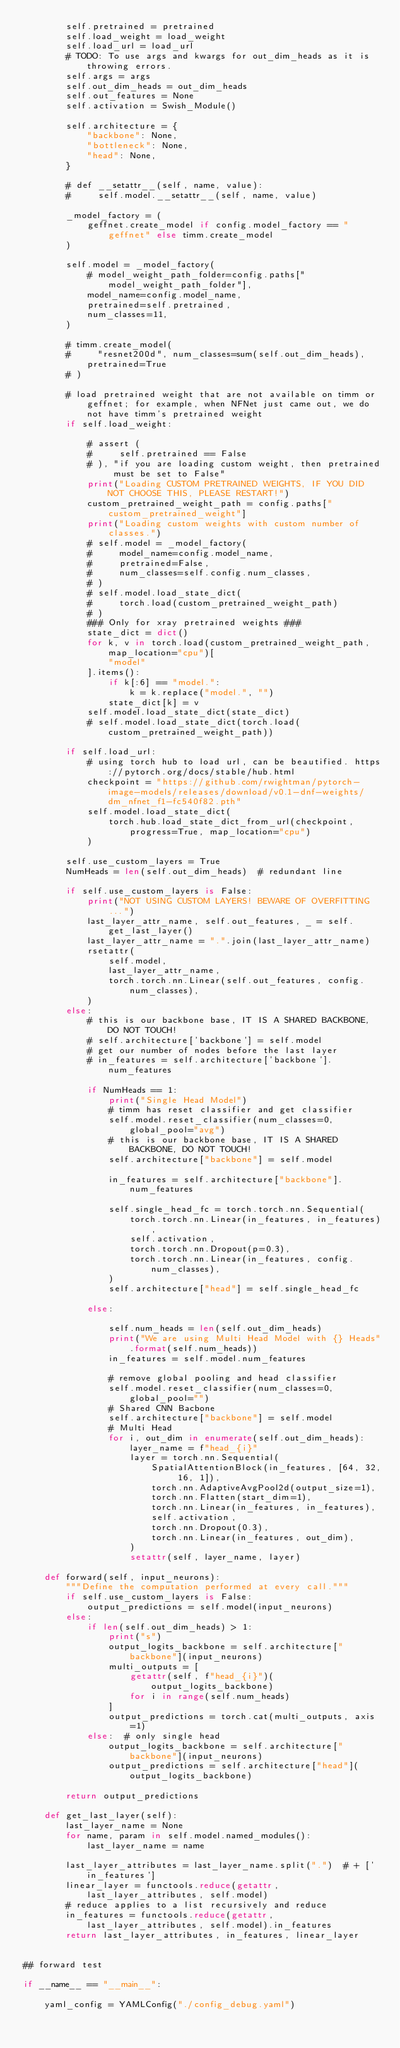<code> <loc_0><loc_0><loc_500><loc_500><_Python_>        self.pretrained = pretrained
        self.load_weight = load_weight
        self.load_url = load_url
        # TODO: To use args and kwargs for out_dim_heads as it is throwing errors.
        self.args = args
        self.out_dim_heads = out_dim_heads
        self.out_features = None
        self.activation = Swish_Module()

        self.architecture = {
            "backbone": None,
            "bottleneck": None,
            "head": None,
        }

        # def __setattr__(self, name, value):
        #     self.model.__setattr__(self, name, value)

        _model_factory = (
            geffnet.create_model if config.model_factory == "geffnet" else timm.create_model
        )

        self.model = _model_factory(
            # model_weight_path_folder=config.paths["model_weight_path_folder"],
            model_name=config.model_name,
            pretrained=self.pretrained,
            num_classes=11,
        )

        # timm.create_model(
        #     "resnet200d", num_classes=sum(self.out_dim_heads), pretrained=True
        # )

        # load pretrained weight that are not available on timm or geffnet; for example, when NFNet just came out, we do not have timm's pretrained weight
        if self.load_weight:

            # assert (
            #     self.pretrained == False
            # ), "if you are loading custom weight, then pretrained must be set to False"
            print("Loading CUSTOM PRETRAINED WEIGHTS, IF YOU DID NOT CHOOSE THIS, PLEASE RESTART!")
            custom_pretrained_weight_path = config.paths["custom_pretrained_weight"]
            print("Loading custom weights with custom number of classes.")
            # self.model = _model_factory(
            #     model_name=config.model_name,
            #     pretrained=False,
            #     num_classes=self.config.num_classes,
            # )
            # self.model.load_state_dict(
            #     torch.load(custom_pretrained_weight_path)
            # )
            ### Only for xray pretrained weights ###
            state_dict = dict()
            for k, v in torch.load(custom_pretrained_weight_path, map_location="cpu")[
                "model"
            ].items():
                if k[:6] == "model.":
                    k = k.replace("model.", "")
                state_dict[k] = v
            self.model.load_state_dict(state_dict)
            # self.model.load_state_dict(torch.load(custom_pretrained_weight_path))

        if self.load_url:
            # using torch hub to load url, can be beautified. https://pytorch.org/docs/stable/hub.html
            checkpoint = "https://github.com/rwightman/pytorch-image-models/releases/download/v0.1-dnf-weights/dm_nfnet_f1-fc540f82.pth"
            self.model.load_state_dict(
                torch.hub.load_state_dict_from_url(checkpoint, progress=True, map_location="cpu")
            )

        self.use_custom_layers = True
        NumHeads = len(self.out_dim_heads)  # redundant line

        if self.use_custom_layers is False:
            print("NOT USING CUSTOM LAYERS! BEWARE OF OVERFITTING...")
            last_layer_attr_name, self.out_features, _ = self.get_last_layer()
            last_layer_attr_name = ".".join(last_layer_attr_name)
            rsetattr(
                self.model,
                last_layer_attr_name,
                torch.torch.nn.Linear(self.out_features, config.num_classes),
            )
        else:
            # this is our backbone base, IT IS A SHARED BACKBONE, DO NOT TOUCH!
            # self.architecture['backbone'] = self.model
            # get our number of nodes before the last layer
            # in_features = self.architecture['backbone'].num_features

            if NumHeads == 1:
                print("Single Head Model")
                # timm has reset classifier and get classifier
                self.model.reset_classifier(num_classes=0, global_pool="avg")
                # this is our backbone base, IT IS A SHARED BACKBONE, DO NOT TOUCH!
                self.architecture["backbone"] = self.model

                in_features = self.architecture["backbone"].num_features

                self.single_head_fc = torch.torch.nn.Sequential(
                    torch.torch.nn.Linear(in_features, in_features),
                    self.activation,
                    torch.torch.nn.Dropout(p=0.3),
                    torch.torch.nn.Linear(in_features, config.num_classes),
                )
                self.architecture["head"] = self.single_head_fc

            else:

                self.num_heads = len(self.out_dim_heads)
                print("We are using Multi Head Model with {} Heads".format(self.num_heads))
                in_features = self.model.num_features

                # remove global pooling and head classifier
                self.model.reset_classifier(num_classes=0, global_pool="")
                # Shared CNN Bacbone
                self.architecture["backbone"] = self.model
                # Multi Head
                for i, out_dim in enumerate(self.out_dim_heads):
                    layer_name = f"head_{i}"
                    layer = torch.nn.Sequential(
                        SpatialAttentionBlock(in_features, [64, 32, 16, 1]),
                        torch.nn.AdaptiveAvgPool2d(output_size=1),
                        torch.nn.Flatten(start_dim=1),
                        torch.nn.Linear(in_features, in_features),
                        self.activation,
                        torch.nn.Dropout(0.3),
                        torch.nn.Linear(in_features, out_dim),
                    )
                    setattr(self, layer_name, layer)

    def forward(self, input_neurons):
        """Define the computation performed at every call."""
        if self.use_custom_layers is False:
            output_predictions = self.model(input_neurons)
        else:
            if len(self.out_dim_heads) > 1:
                print("s")
                output_logits_backbone = self.architecture["backbone"](input_neurons)
                multi_outputs = [
                    getattr(self, f"head_{i}")(output_logits_backbone)
                    for i in range(self.num_heads)
                ]
                output_predictions = torch.cat(multi_outputs, axis=1)
            else:  # only single head
                output_logits_backbone = self.architecture["backbone"](input_neurons)
                output_predictions = self.architecture["head"](output_logits_backbone)

        return output_predictions

    def get_last_layer(self):
        last_layer_name = None
        for name, param in self.model.named_modules():
            last_layer_name = name

        last_layer_attributes = last_layer_name.split(".")  # + ['in_features']
        linear_layer = functools.reduce(getattr, last_layer_attributes, self.model)
        # reduce applies to a list recursively and reduce
        in_features = functools.reduce(getattr, last_layer_attributes, self.model).in_features
        return last_layer_attributes, in_features, linear_layer


## forward test

if __name__ == "__main__":

    yaml_config = YAMLConfig("./config_debug.yaml")</code> 